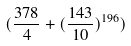<formula> <loc_0><loc_0><loc_500><loc_500>( \frac { 3 7 8 } { 4 } + ( \frac { 1 4 3 } { 1 0 } ) ^ { 1 9 6 } )</formula> 